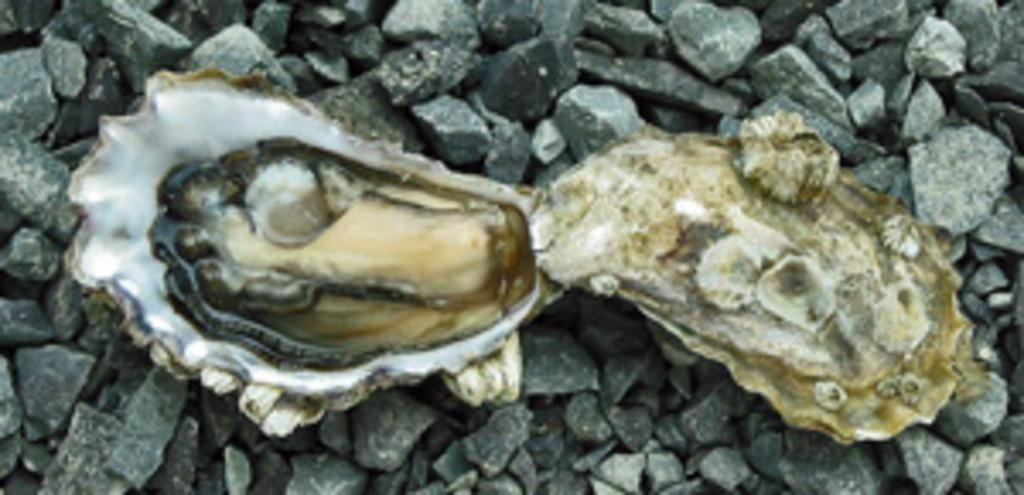What is the main object in the image? There is a shell in the image. What can be seen in the background of the image? There are stones visible in the background of the image. What type of shoes is the shell wearing in the image? The shell is not wearing shoes, as it is an inanimate object and does not have the ability to wear shoes. 